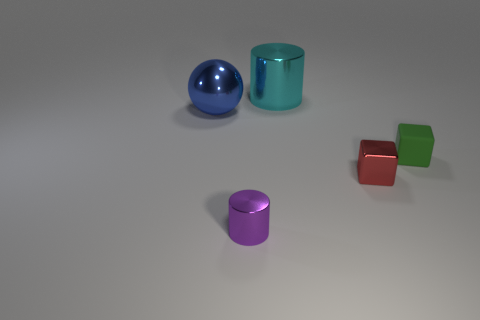Is there any other thing that is made of the same material as the green cube?
Offer a terse response. No. Are there any green objects of the same size as the purple metal cylinder?
Give a very brief answer. Yes. How many metal objects are either small brown cylinders or cyan cylinders?
Keep it short and to the point. 1. How many tiny yellow objects are there?
Make the answer very short. 0. Is the cylinder that is in front of the cyan cylinder made of the same material as the big thing that is on the left side of the cyan cylinder?
Keep it short and to the point. Yes. What size is the sphere that is made of the same material as the large cylinder?
Your answer should be compact. Large. What is the shape of the thing that is behind the blue metallic object?
Offer a very short reply. Cylinder. Are any spheres visible?
Offer a terse response. Yes. What is the shape of the small shiny thing that is right of the metal cylinder behind the cylinder in front of the large metallic ball?
Offer a terse response. Cube. There is a purple metal cylinder; what number of green rubber things are behind it?
Offer a terse response. 1. 